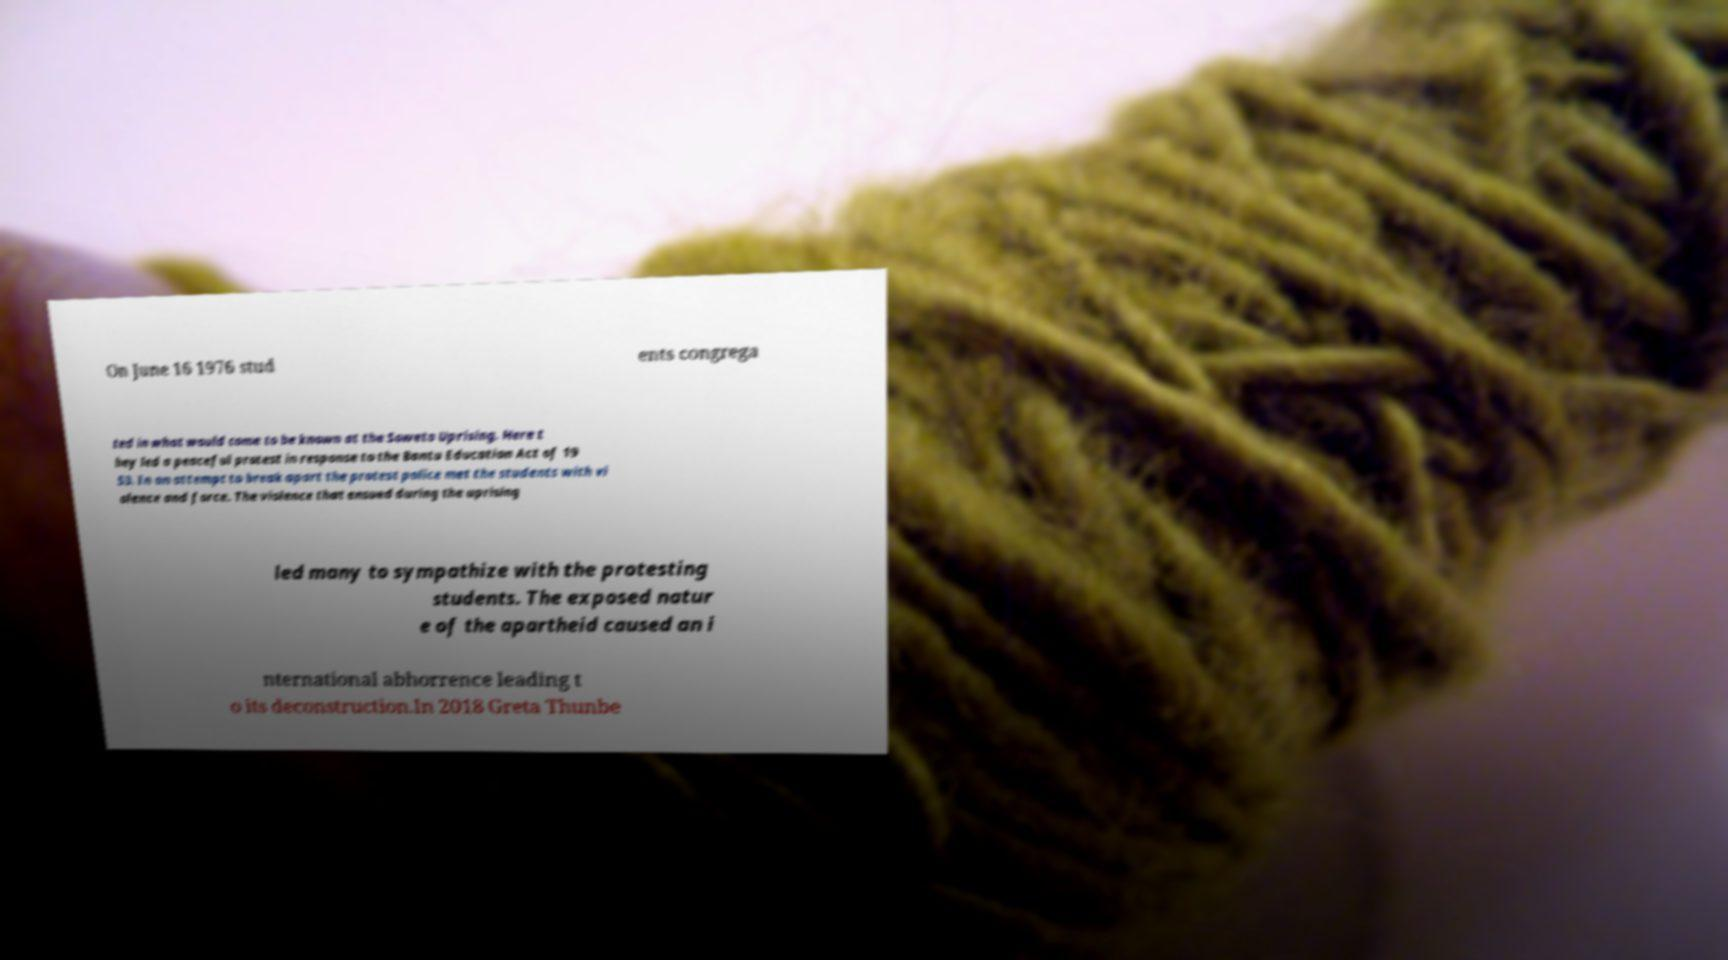Can you read and provide the text displayed in the image?This photo seems to have some interesting text. Can you extract and type it out for me? On June 16 1976 stud ents congrega ted in what would come to be known at the Soweto Uprising. Here t hey led a peaceful protest in response to the Bantu Education Act of 19 53. In an attempt to break apart the protest police met the students with vi olence and force. The violence that ensued during the uprising led many to sympathize with the protesting students. The exposed natur e of the apartheid caused an i nternational abhorrence leading t o its deconstruction.In 2018 Greta Thunbe 